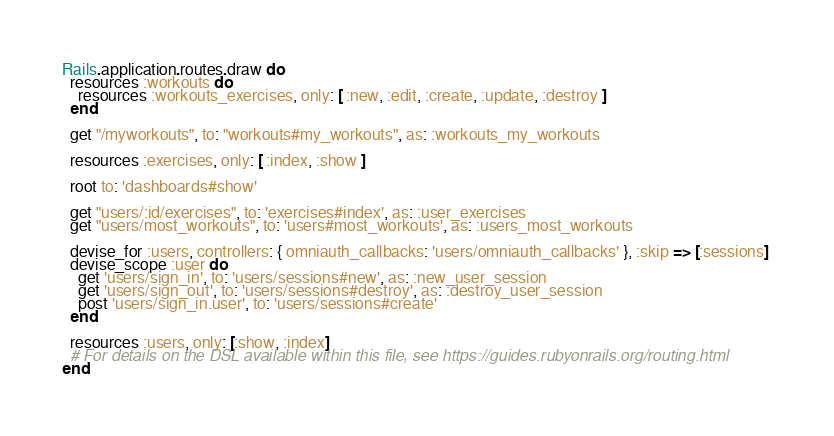Convert code to text. <code><loc_0><loc_0><loc_500><loc_500><_Ruby_>Rails.application.routes.draw do
  resources :workouts do
    resources :workouts_exercises, only: [ :new, :edit, :create, :update, :destroy ]
  end

  get "/myworkouts", to: "workouts#my_workouts", as: :workouts_my_workouts

  resources :exercises, only: [ :index, :show ]

  root to: 'dashboards#show'
  
  get "users/:id/exercises", to: 'exercises#index', as: :user_exercises
  get "users/most_workouts", to: 'users#most_workouts', as: :users_most_workouts

  devise_for :users, controllers: { omniauth_callbacks: 'users/omniauth_callbacks' }, :skip => [:sessions] 
  devise_scope :user do
    get 'users/sign_in', to: 'users/sessions#new', as: :new_user_session
    get 'users/sign_out', to: 'users/sessions#destroy', as: :destroy_user_session
    post 'users/sign_in.user', to: 'users/sessions#create'
  end

  resources :users, only: [:show, :index]
  # For details on the DSL available within this file, see https://guides.rubyonrails.org/routing.html
end
</code> 